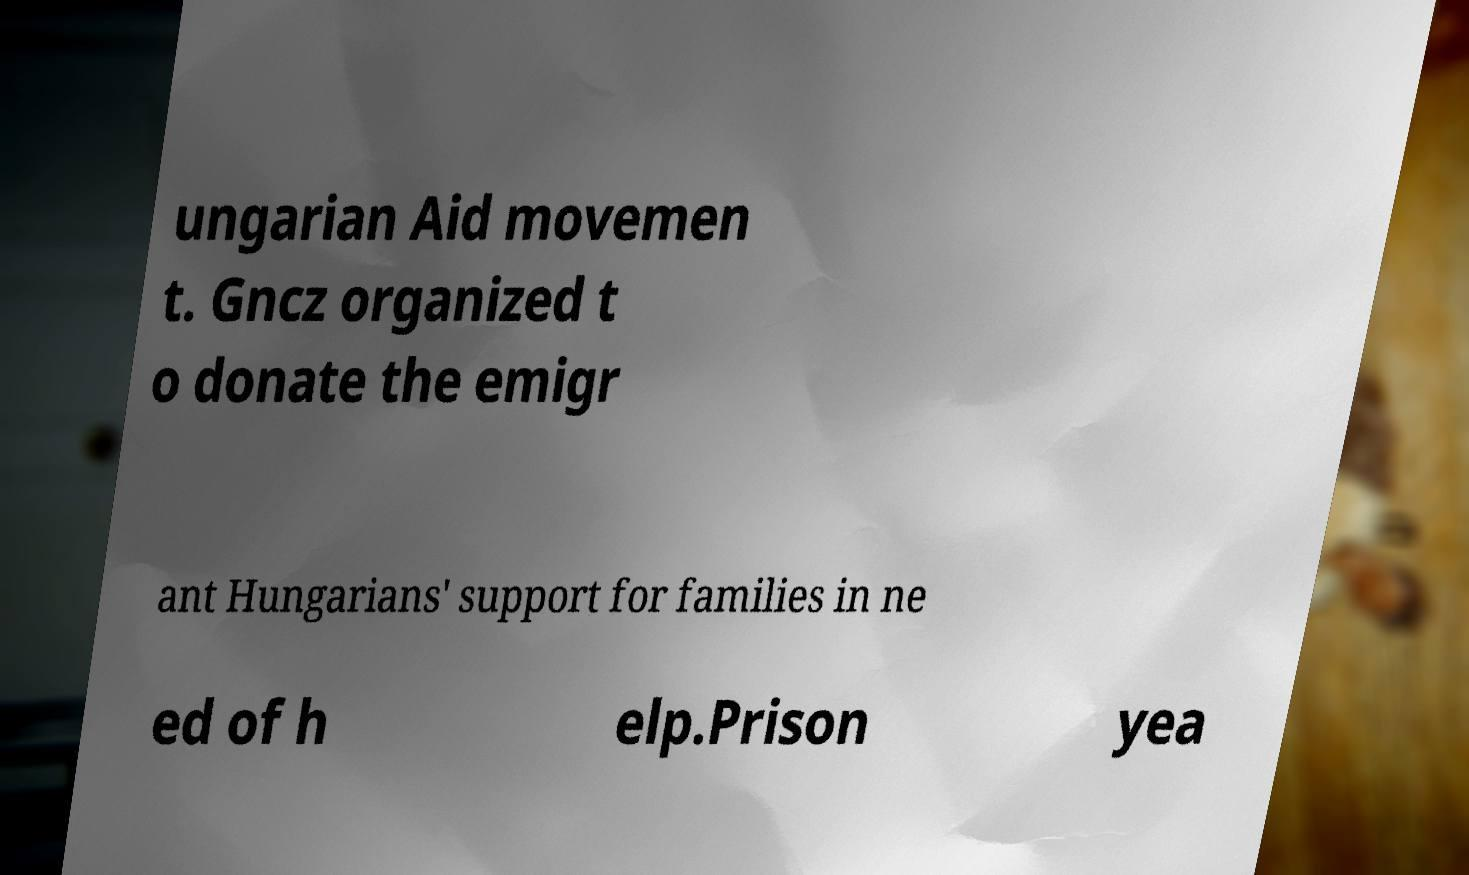Can you read and provide the text displayed in the image?This photo seems to have some interesting text. Can you extract and type it out for me? ungarian Aid movemen t. Gncz organized t o donate the emigr ant Hungarians' support for families in ne ed of h elp.Prison yea 